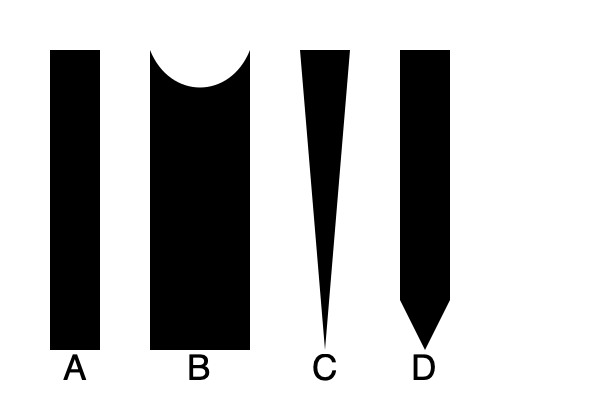Match the following traditional Kalaripayattu weapons to their illustrated silhouettes:

1. Urumi (flexible sword)
2. Maduvu (deer horn dagger)
3. Kattari (push dagger)
4. Otta (curved stick)

Write your answer as a sequence of letter-number pairs (e.g., A1, B2, C3, D4). To match the traditional Kalaripayattu weapons to their silhouettes, let's analyze each weapon's characteristics and compare them to the illustrations:

1. Urumi (flexible sword):
   - Known for its flexible, whip-like blade
   - In the silhouette, weapon A shows a long, straight form, which could represent the Urumi when held straight

2. Maduvu (deer horn dagger):
   - Shaped like deer antlers with a curved, forked design
   - Silhouette B clearly shows a curved, forked shape resembling deer antlers

3. Kattari (push dagger):
   - A triangular blade designed for thrusting
   - Silhouette C displays a triangular shape, consistent with the Kattari's design

4. Otta (curved stick):
   - A curved wooden stick used for striking and blocking
   - Silhouette D shows a long, slightly curved form with a thicker end, matching the Otta's description

Based on these observations, we can match the weapons to their silhouettes as follows:
- A: Urumi
- B: Maduvu
- C: Kattari
- D: Otta
Answer: A1, B2, C3, D4 